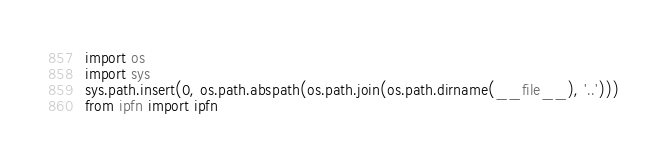Convert code to text. <code><loc_0><loc_0><loc_500><loc_500><_Python_>import os
import sys
sys.path.insert(0, os.path.abspath(os.path.join(os.path.dirname(__file__), '..')))
from ipfn import ipfn
</code> 